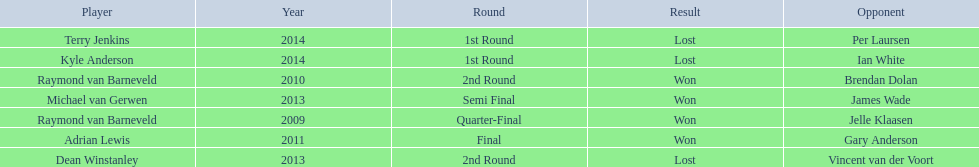What are all the years? 2009, 2010, 2011, 2013, 2013, 2014, 2014. Of these, which ones are 2014? 2014, 2014. Of these dates which one is associated with a player other than kyle anderson? 2014. What is the player name associated with this year? Terry Jenkins. 